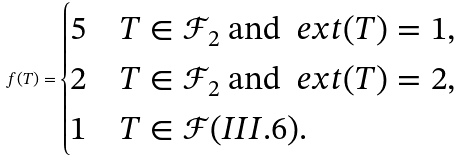Convert formula to latex. <formula><loc_0><loc_0><loc_500><loc_500>f ( T ) = \begin{cases} 5 & T \in \mathcal { F } _ { 2 } \text { and } \ e x t ( T ) = 1 , \\ 2 & T \in \mathcal { F } _ { 2 } \text { and } \ e x t ( T ) = 2 , \\ 1 & T \in \mathcal { F } ( I I I . 6 ) . \end{cases}</formula> 